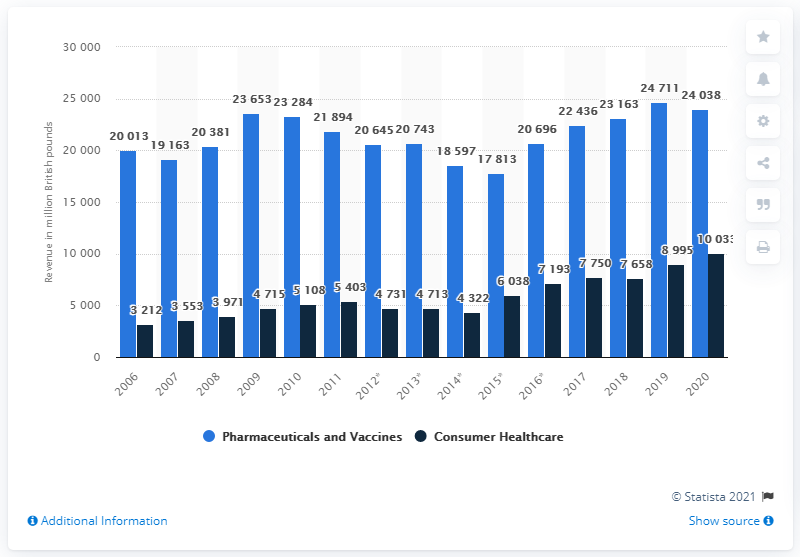Point out several critical features in this image. In 2020, GlaxoSmithKline generated approximately 240,380 million USD in revenue. 